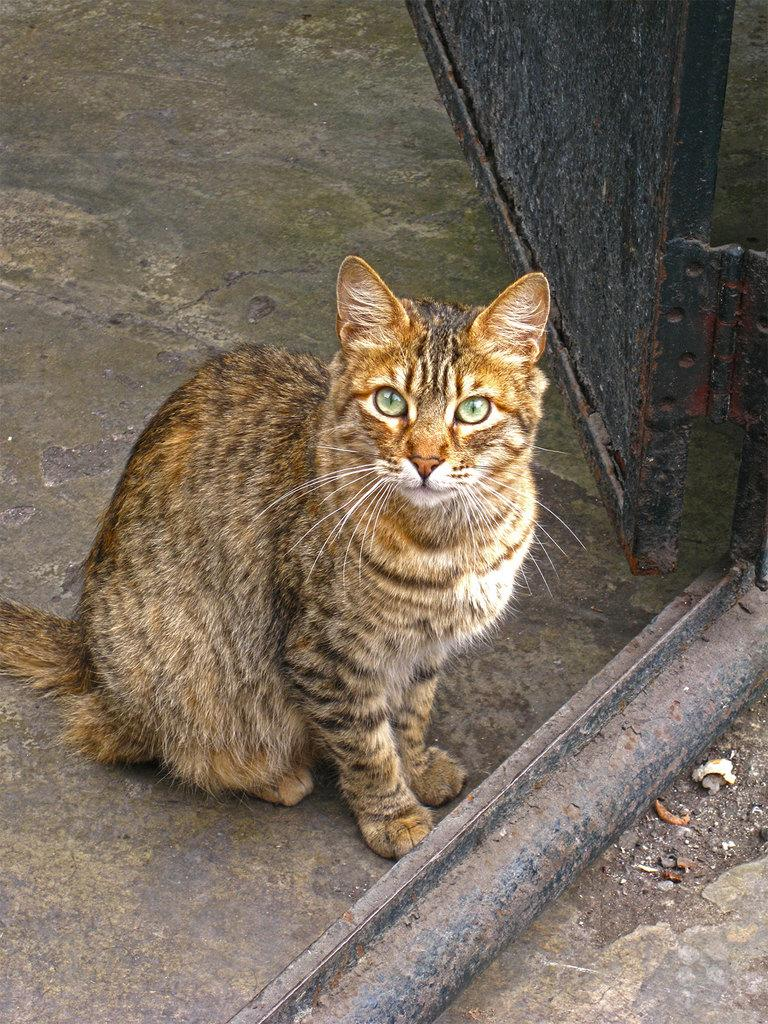What structure can be seen in the image? There is a gate in the image. What type of animal is near the gate? A cat is present beside the gate. What type of unit is being measured by the cat in the image? There is no unit being measured in the image, as the cat is simply present beside the gate. 